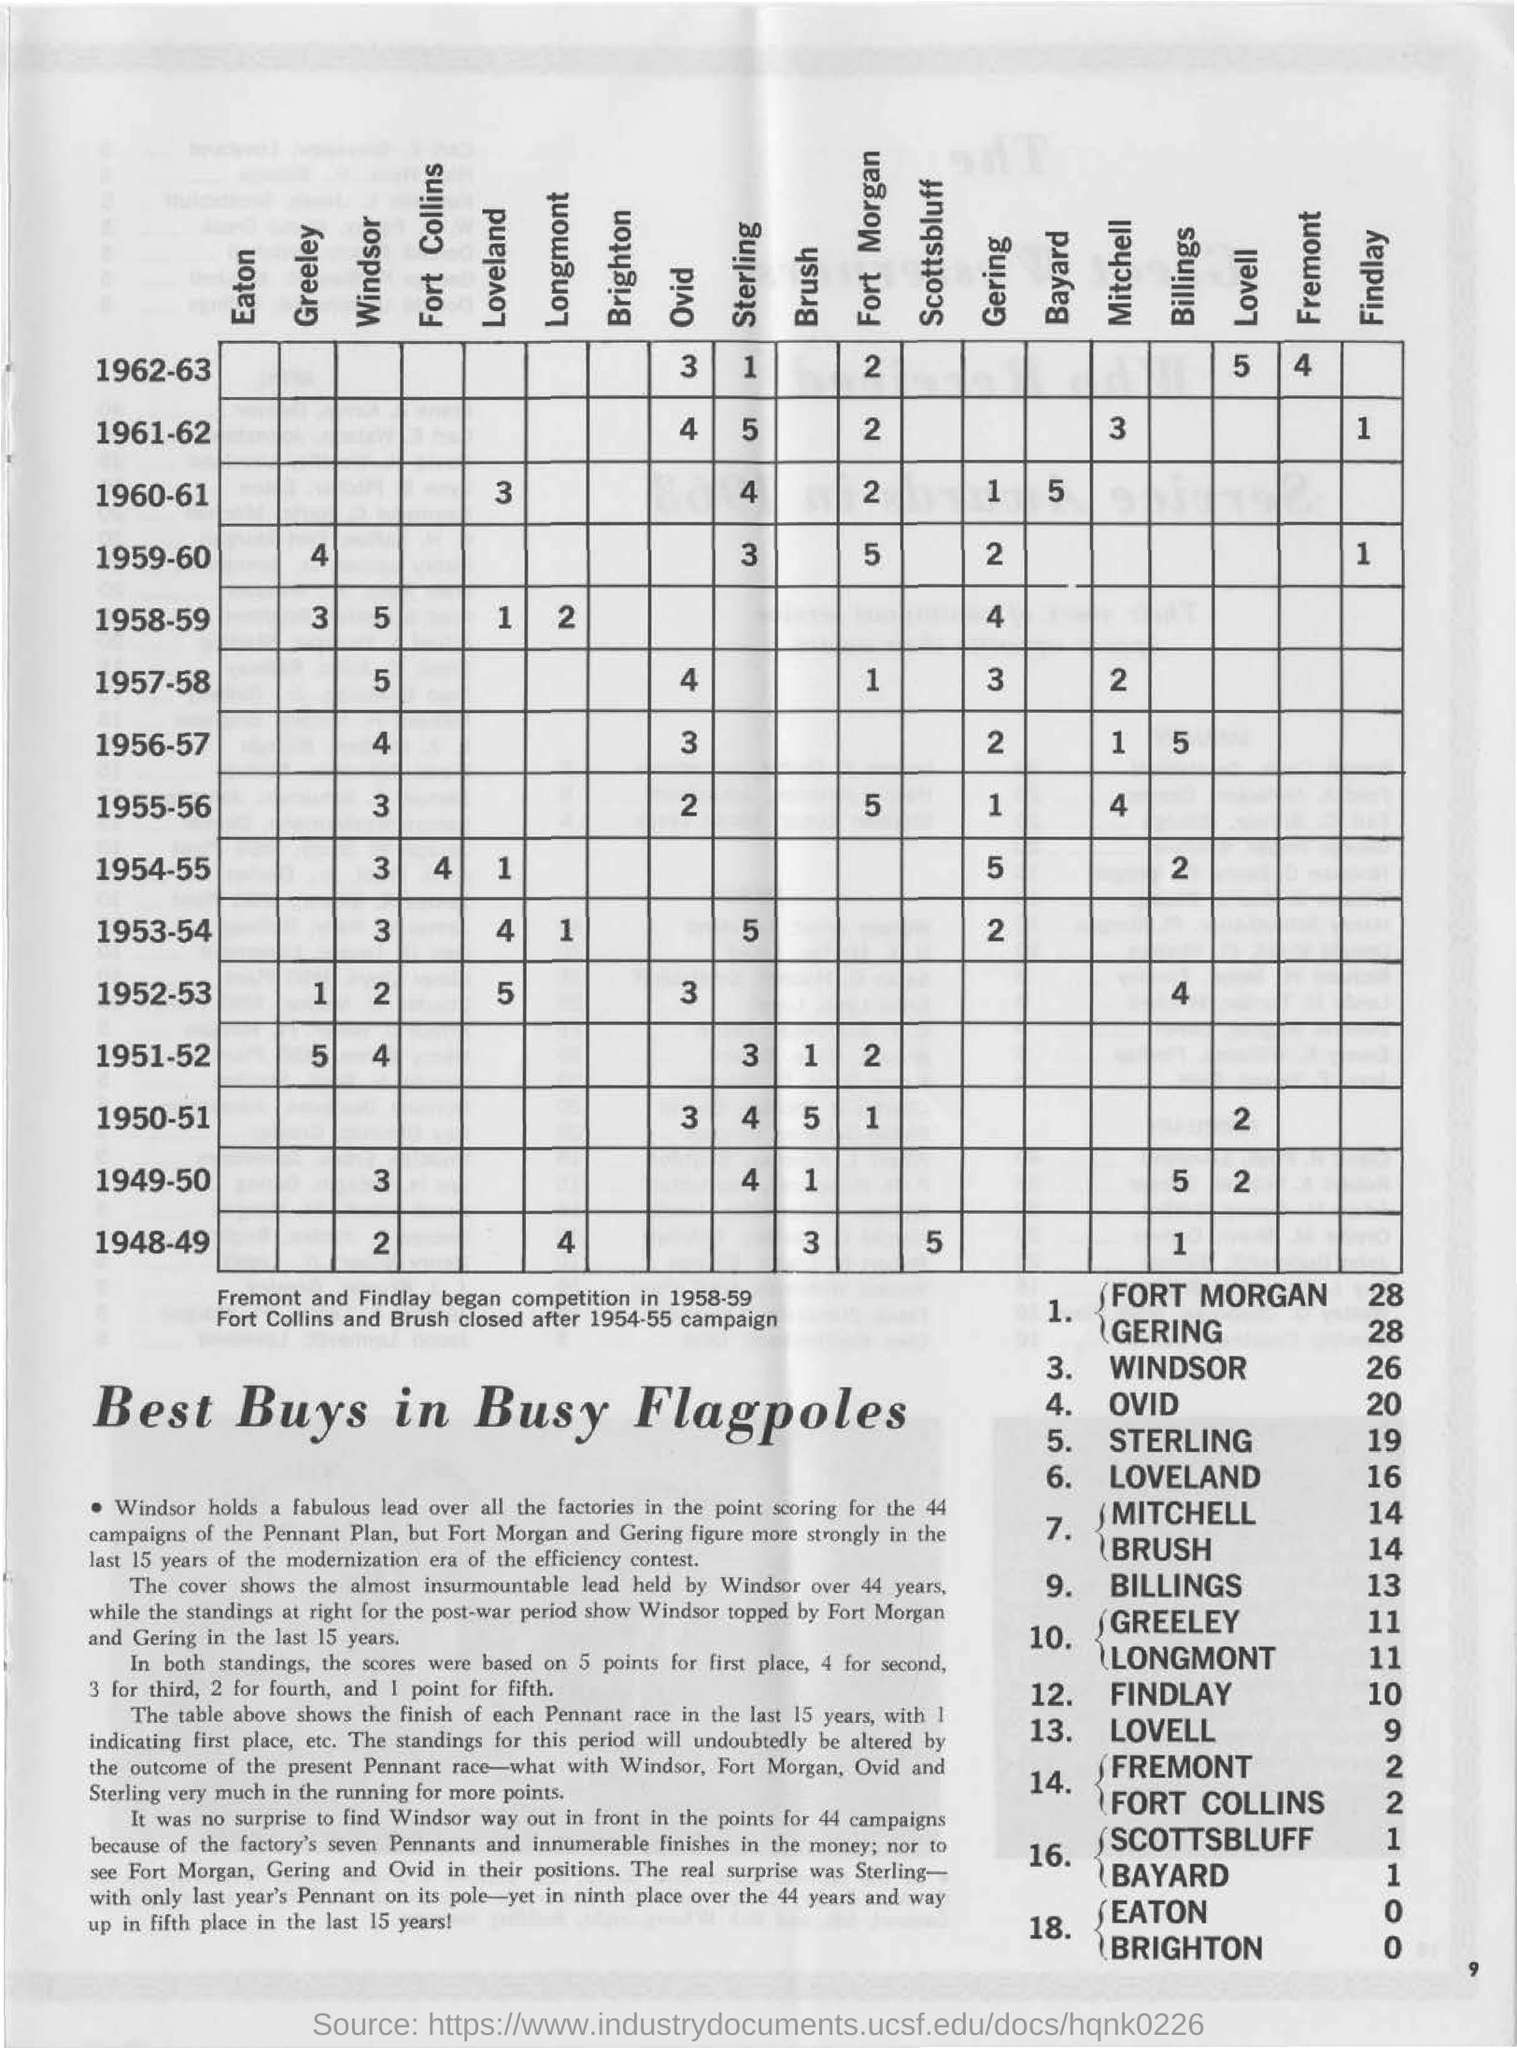What is the number on the "windsor" & "1958-59" cell?
Give a very brief answer. 5. What is the number on the "windsor" & "1957-58" cell?
Your response must be concise. 5. What is the number on the "loveland" & "1958-59" cell?
Provide a short and direct response. 1. What is the number on the "gering" & "1957-58" cell?
Make the answer very short. 3. 